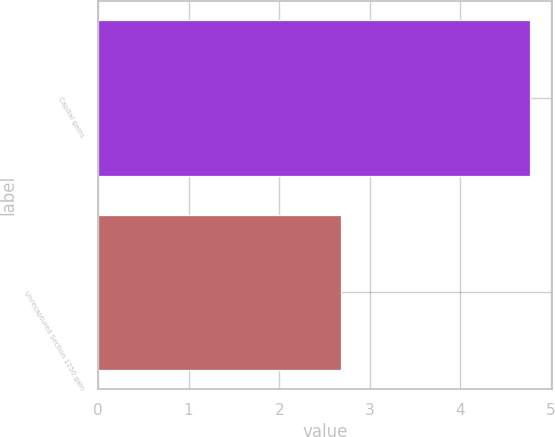<chart> <loc_0><loc_0><loc_500><loc_500><bar_chart><fcel>Capital gains<fcel>Unrecaptured Section 1250 gain<nl><fcel>4.77<fcel>2.68<nl></chart> 